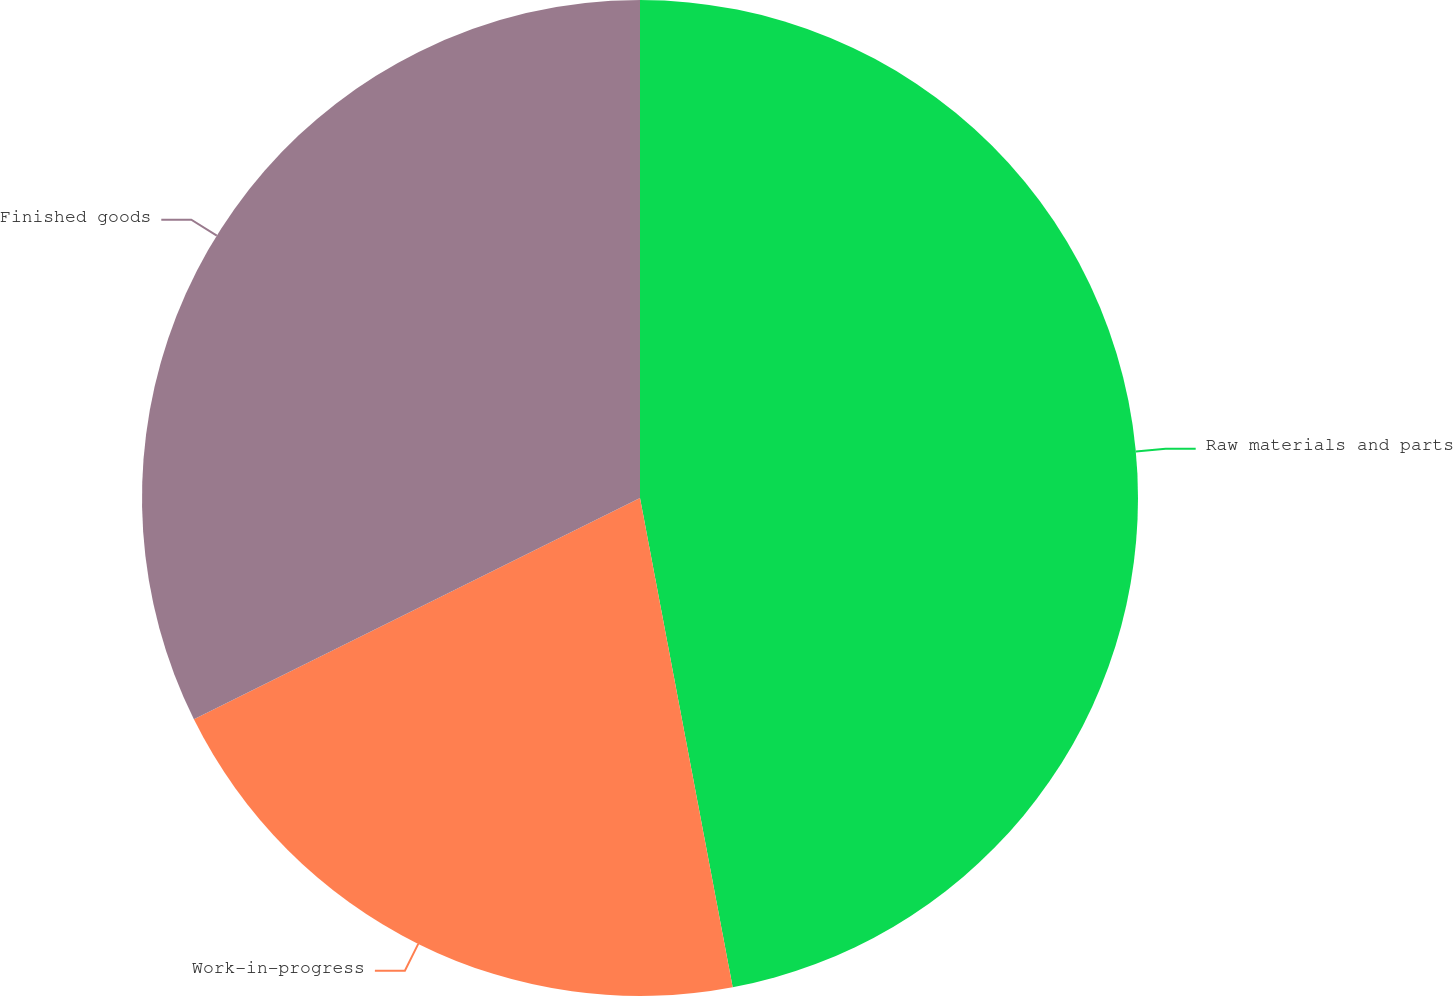<chart> <loc_0><loc_0><loc_500><loc_500><pie_chart><fcel>Raw materials and parts<fcel>Work-in-progress<fcel>Finished goods<nl><fcel>47.02%<fcel>20.65%<fcel>32.33%<nl></chart> 